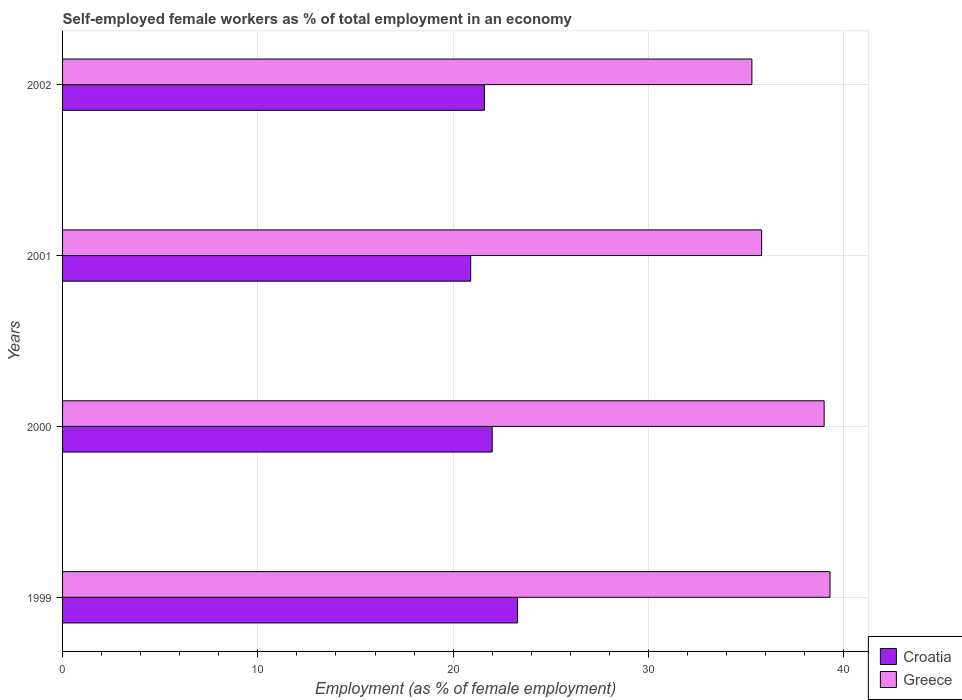How many different coloured bars are there?
Your response must be concise. 2. Are the number of bars per tick equal to the number of legend labels?
Your answer should be very brief. Yes. Are the number of bars on each tick of the Y-axis equal?
Ensure brevity in your answer.  Yes. How many bars are there on the 2nd tick from the bottom?
Make the answer very short. 2. What is the label of the 1st group of bars from the top?
Make the answer very short. 2002. What is the percentage of self-employed female workers in Croatia in 2002?
Ensure brevity in your answer.  21.6. Across all years, what is the maximum percentage of self-employed female workers in Croatia?
Keep it short and to the point. 23.3. Across all years, what is the minimum percentage of self-employed female workers in Croatia?
Keep it short and to the point. 20.9. In which year was the percentage of self-employed female workers in Croatia maximum?
Your response must be concise. 1999. In which year was the percentage of self-employed female workers in Croatia minimum?
Provide a succinct answer. 2001. What is the total percentage of self-employed female workers in Croatia in the graph?
Your response must be concise. 87.8. What is the difference between the percentage of self-employed female workers in Croatia in 1999 and that in 2002?
Provide a succinct answer. 1.7. What is the difference between the percentage of self-employed female workers in Greece in 1999 and the percentage of self-employed female workers in Croatia in 2002?
Your answer should be compact. 17.7. What is the average percentage of self-employed female workers in Greece per year?
Provide a succinct answer. 37.35. In the year 2000, what is the difference between the percentage of self-employed female workers in Greece and percentage of self-employed female workers in Croatia?
Keep it short and to the point. 17. What is the ratio of the percentage of self-employed female workers in Croatia in 2001 to that in 2002?
Ensure brevity in your answer.  0.97. Is the percentage of self-employed female workers in Greece in 1999 less than that in 2001?
Your response must be concise. No. Is the difference between the percentage of self-employed female workers in Greece in 1999 and 2002 greater than the difference between the percentage of self-employed female workers in Croatia in 1999 and 2002?
Keep it short and to the point. Yes. What is the difference between the highest and the second highest percentage of self-employed female workers in Greece?
Provide a succinct answer. 0.3. What is the difference between the highest and the lowest percentage of self-employed female workers in Croatia?
Ensure brevity in your answer.  2.4. What does the 2nd bar from the top in 2002 represents?
Offer a very short reply. Croatia. How many bars are there?
Make the answer very short. 8. Where does the legend appear in the graph?
Your answer should be very brief. Bottom right. What is the title of the graph?
Provide a short and direct response. Self-employed female workers as % of total employment in an economy. What is the label or title of the X-axis?
Your answer should be compact. Employment (as % of female employment). What is the label or title of the Y-axis?
Give a very brief answer. Years. What is the Employment (as % of female employment) of Croatia in 1999?
Ensure brevity in your answer.  23.3. What is the Employment (as % of female employment) of Greece in 1999?
Your answer should be very brief. 39.3. What is the Employment (as % of female employment) of Croatia in 2000?
Ensure brevity in your answer.  22. What is the Employment (as % of female employment) in Croatia in 2001?
Your answer should be compact. 20.9. What is the Employment (as % of female employment) in Greece in 2001?
Ensure brevity in your answer.  35.8. What is the Employment (as % of female employment) of Croatia in 2002?
Make the answer very short. 21.6. What is the Employment (as % of female employment) in Greece in 2002?
Ensure brevity in your answer.  35.3. Across all years, what is the maximum Employment (as % of female employment) of Croatia?
Your answer should be compact. 23.3. Across all years, what is the maximum Employment (as % of female employment) in Greece?
Provide a short and direct response. 39.3. Across all years, what is the minimum Employment (as % of female employment) in Croatia?
Provide a short and direct response. 20.9. Across all years, what is the minimum Employment (as % of female employment) in Greece?
Offer a terse response. 35.3. What is the total Employment (as % of female employment) of Croatia in the graph?
Give a very brief answer. 87.8. What is the total Employment (as % of female employment) in Greece in the graph?
Your response must be concise. 149.4. What is the difference between the Employment (as % of female employment) in Croatia in 1999 and that in 2000?
Ensure brevity in your answer.  1.3. What is the difference between the Employment (as % of female employment) of Greece in 1999 and that in 2000?
Your response must be concise. 0.3. What is the difference between the Employment (as % of female employment) of Croatia in 1999 and that in 2001?
Your answer should be compact. 2.4. What is the difference between the Employment (as % of female employment) in Greece in 1999 and that in 2001?
Offer a terse response. 3.5. What is the difference between the Employment (as % of female employment) of Greece in 1999 and that in 2002?
Your response must be concise. 4. What is the difference between the Employment (as % of female employment) of Greece in 2000 and that in 2001?
Your answer should be very brief. 3.2. What is the difference between the Employment (as % of female employment) of Croatia in 2000 and that in 2002?
Provide a short and direct response. 0.4. What is the difference between the Employment (as % of female employment) of Greece in 2000 and that in 2002?
Your answer should be compact. 3.7. What is the difference between the Employment (as % of female employment) in Greece in 2001 and that in 2002?
Ensure brevity in your answer.  0.5. What is the difference between the Employment (as % of female employment) in Croatia in 1999 and the Employment (as % of female employment) in Greece in 2000?
Your answer should be very brief. -15.7. What is the difference between the Employment (as % of female employment) of Croatia in 1999 and the Employment (as % of female employment) of Greece in 2001?
Ensure brevity in your answer.  -12.5. What is the difference between the Employment (as % of female employment) in Croatia in 1999 and the Employment (as % of female employment) in Greece in 2002?
Provide a short and direct response. -12. What is the difference between the Employment (as % of female employment) in Croatia in 2000 and the Employment (as % of female employment) in Greece in 2001?
Offer a very short reply. -13.8. What is the difference between the Employment (as % of female employment) of Croatia in 2001 and the Employment (as % of female employment) of Greece in 2002?
Your response must be concise. -14.4. What is the average Employment (as % of female employment) of Croatia per year?
Ensure brevity in your answer.  21.95. What is the average Employment (as % of female employment) in Greece per year?
Give a very brief answer. 37.35. In the year 2001, what is the difference between the Employment (as % of female employment) of Croatia and Employment (as % of female employment) of Greece?
Keep it short and to the point. -14.9. In the year 2002, what is the difference between the Employment (as % of female employment) of Croatia and Employment (as % of female employment) of Greece?
Offer a terse response. -13.7. What is the ratio of the Employment (as % of female employment) of Croatia in 1999 to that in 2000?
Provide a succinct answer. 1.06. What is the ratio of the Employment (as % of female employment) in Greece in 1999 to that in 2000?
Offer a terse response. 1.01. What is the ratio of the Employment (as % of female employment) of Croatia in 1999 to that in 2001?
Offer a very short reply. 1.11. What is the ratio of the Employment (as % of female employment) of Greece in 1999 to that in 2001?
Provide a short and direct response. 1.1. What is the ratio of the Employment (as % of female employment) in Croatia in 1999 to that in 2002?
Your response must be concise. 1.08. What is the ratio of the Employment (as % of female employment) of Greece in 1999 to that in 2002?
Your answer should be very brief. 1.11. What is the ratio of the Employment (as % of female employment) of Croatia in 2000 to that in 2001?
Provide a short and direct response. 1.05. What is the ratio of the Employment (as % of female employment) in Greece in 2000 to that in 2001?
Ensure brevity in your answer.  1.09. What is the ratio of the Employment (as % of female employment) of Croatia in 2000 to that in 2002?
Keep it short and to the point. 1.02. What is the ratio of the Employment (as % of female employment) in Greece in 2000 to that in 2002?
Provide a short and direct response. 1.1. What is the ratio of the Employment (as % of female employment) of Croatia in 2001 to that in 2002?
Keep it short and to the point. 0.97. What is the ratio of the Employment (as % of female employment) in Greece in 2001 to that in 2002?
Ensure brevity in your answer.  1.01. What is the difference between the highest and the lowest Employment (as % of female employment) in Croatia?
Offer a terse response. 2.4. 